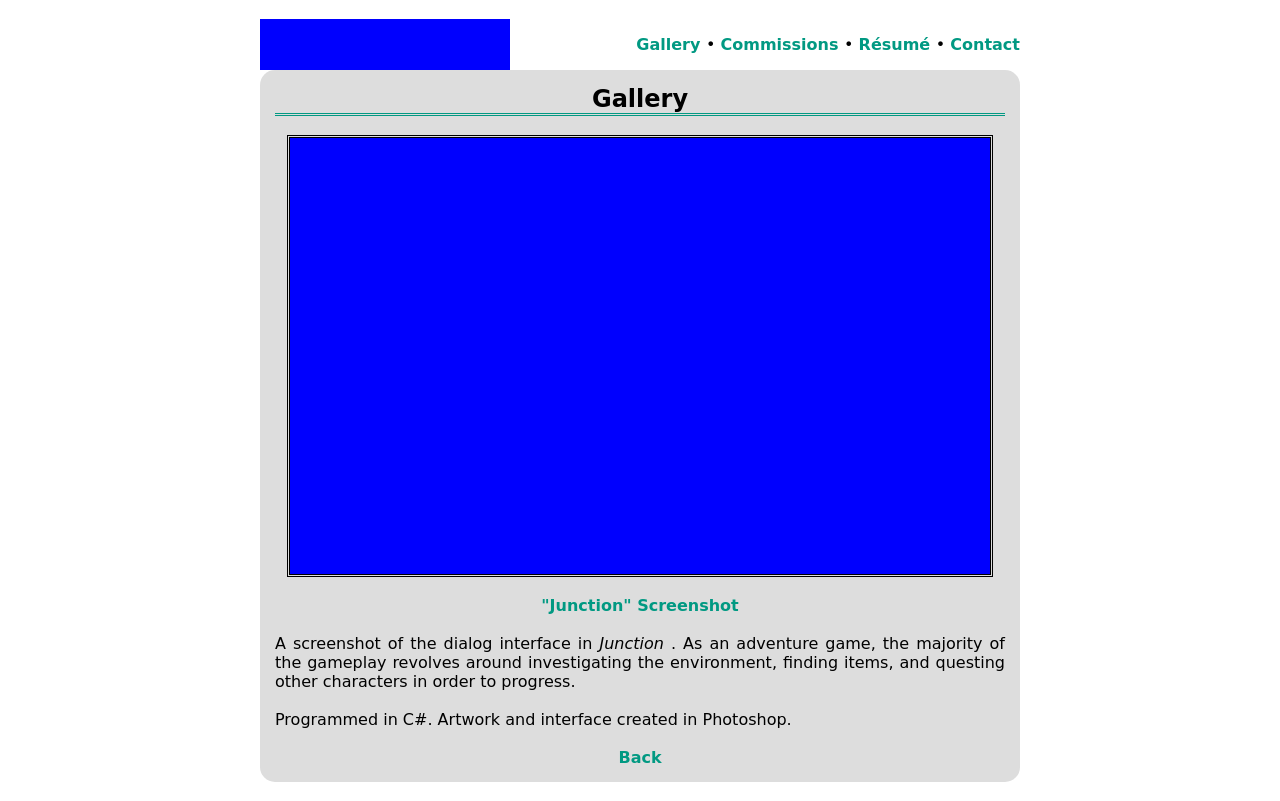How can I start building this website with HTML from the ground up? To start building a website with HTML, you'll begin by setting up the basic structure. Here is a simple example to get you started:

```html
<!DOCTYPE html>
<html>
<head>
    <title>Your Website's Title</title>
</head>
<body>
    <h1>Hello, welcome to my website!</h1>
    <p>This is a paragraph to add some content to your homepage.</p>
</body>
</html>
```
This code sets up a basic webpage with a heading and a paragraph. From here, you can expand by adding more HTML elements like images, links, lists, and styles with CSS. 